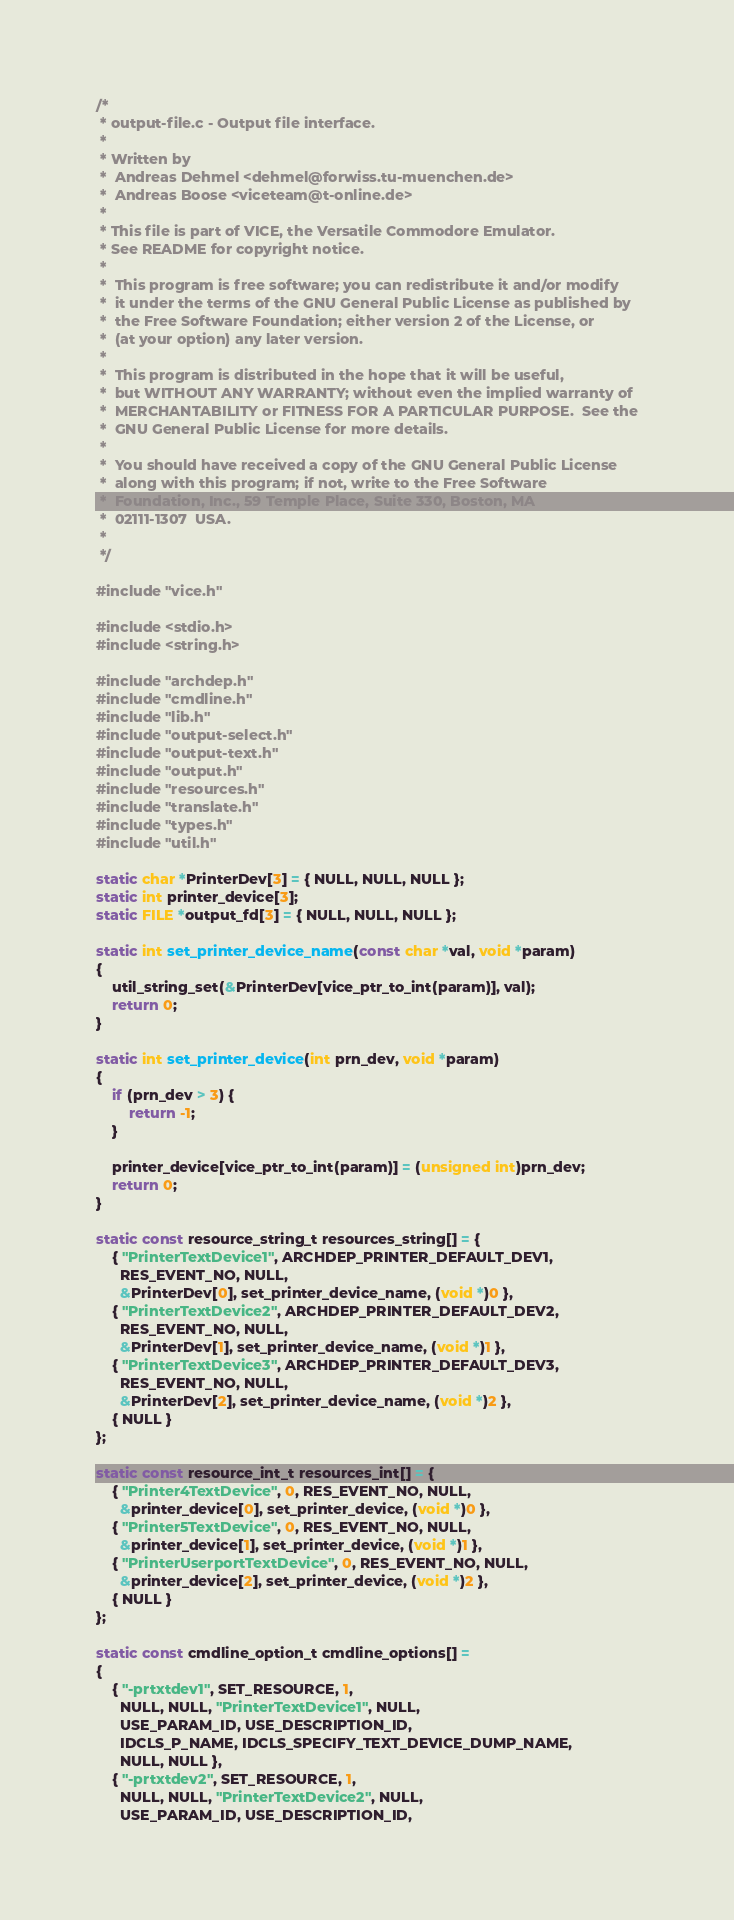<code> <loc_0><loc_0><loc_500><loc_500><_C_>/*
 * output-file.c - Output file interface.
 *
 * Written by
 *  Andreas Dehmel <dehmel@forwiss.tu-muenchen.de>
 *  Andreas Boose <viceteam@t-online.de>
 *
 * This file is part of VICE, the Versatile Commodore Emulator.
 * See README for copyright notice.
 *
 *  This program is free software; you can redistribute it and/or modify
 *  it under the terms of the GNU General Public License as published by
 *  the Free Software Foundation; either version 2 of the License, or
 *  (at your option) any later version.
 *
 *  This program is distributed in the hope that it will be useful,
 *  but WITHOUT ANY WARRANTY; without even the implied warranty of
 *  MERCHANTABILITY or FITNESS FOR A PARTICULAR PURPOSE.  See the
 *  GNU General Public License for more details.
 *
 *  You should have received a copy of the GNU General Public License
 *  along with this program; if not, write to the Free Software
 *  Foundation, Inc., 59 Temple Place, Suite 330, Boston, MA
 *  02111-1307  USA.
 *
 */

#include "vice.h"

#include <stdio.h>
#include <string.h>

#include "archdep.h"
#include "cmdline.h"
#include "lib.h"
#include "output-select.h"
#include "output-text.h"
#include "output.h"
#include "resources.h"
#include "translate.h"
#include "types.h"
#include "util.h"

static char *PrinterDev[3] = { NULL, NULL, NULL };
static int printer_device[3];
static FILE *output_fd[3] = { NULL, NULL, NULL };

static int set_printer_device_name(const char *val, void *param)
{
    util_string_set(&PrinterDev[vice_ptr_to_int(param)], val);
    return 0;
}

static int set_printer_device(int prn_dev, void *param)
{
    if (prn_dev > 3) {
        return -1;
    }

    printer_device[vice_ptr_to_int(param)] = (unsigned int)prn_dev;
    return 0;
}

static const resource_string_t resources_string[] = {
    { "PrinterTextDevice1", ARCHDEP_PRINTER_DEFAULT_DEV1,
      RES_EVENT_NO, NULL,
      &PrinterDev[0], set_printer_device_name, (void *)0 },
    { "PrinterTextDevice2", ARCHDEP_PRINTER_DEFAULT_DEV2,
      RES_EVENT_NO, NULL,
      &PrinterDev[1], set_printer_device_name, (void *)1 },
    { "PrinterTextDevice3", ARCHDEP_PRINTER_DEFAULT_DEV3,
      RES_EVENT_NO, NULL,
      &PrinterDev[2], set_printer_device_name, (void *)2 },
    { NULL }
};

static const resource_int_t resources_int[] = {
    { "Printer4TextDevice", 0, RES_EVENT_NO, NULL,
      &printer_device[0], set_printer_device, (void *)0 },
    { "Printer5TextDevice", 0, RES_EVENT_NO, NULL,
      &printer_device[1], set_printer_device, (void *)1 },
    { "PrinterUserportTextDevice", 0, RES_EVENT_NO, NULL,
      &printer_device[2], set_printer_device, (void *)2 },
    { NULL }
};

static const cmdline_option_t cmdline_options[] =
{
    { "-prtxtdev1", SET_RESOURCE, 1,
      NULL, NULL, "PrinterTextDevice1", NULL,
      USE_PARAM_ID, USE_DESCRIPTION_ID,
      IDCLS_P_NAME, IDCLS_SPECIFY_TEXT_DEVICE_DUMP_NAME,
      NULL, NULL },
    { "-prtxtdev2", SET_RESOURCE, 1,
      NULL, NULL, "PrinterTextDevice2", NULL,
      USE_PARAM_ID, USE_DESCRIPTION_ID,</code> 